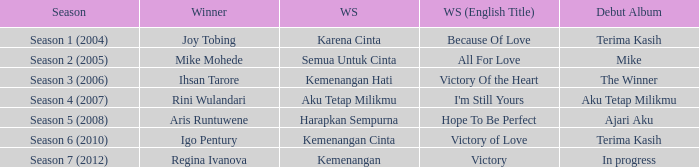Which winning song had a debut album in progress? Kemenangan. 